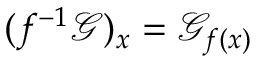Convert formula to latex. <formula><loc_0><loc_0><loc_500><loc_500>( f ^ { - 1 } { \mathcal { G } } ) _ { x } = { \mathcal { G } } _ { f ( x ) }</formula> 